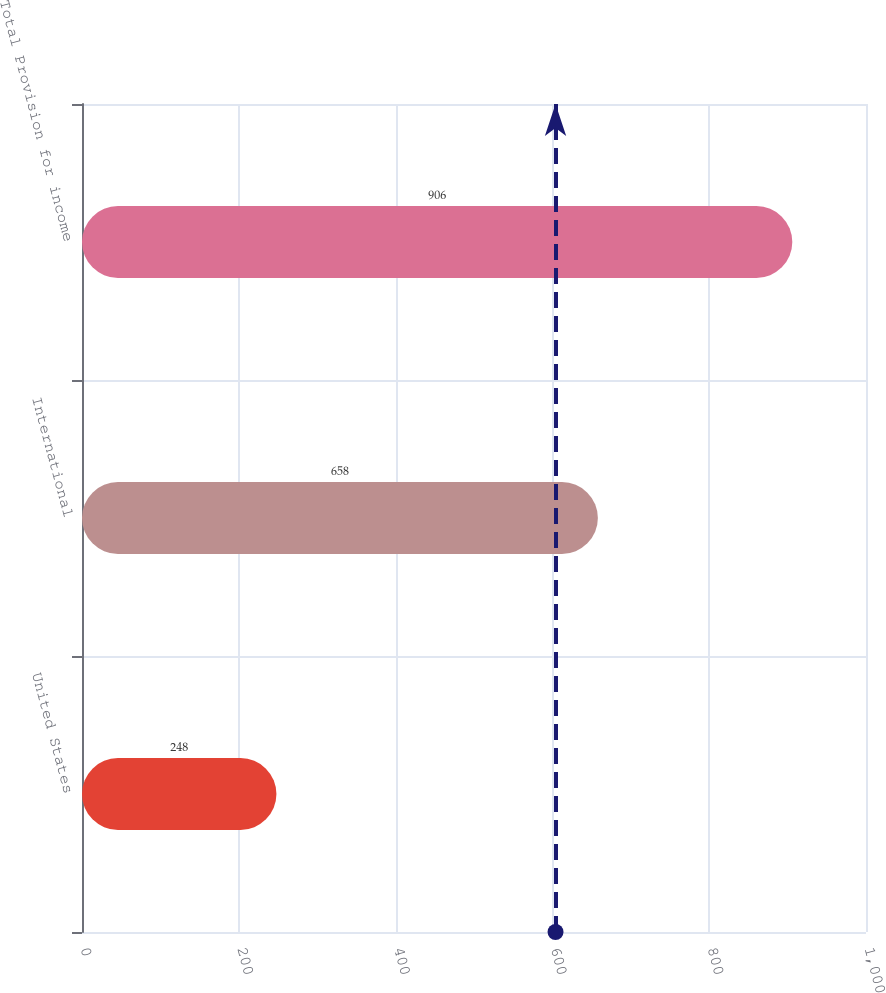Convert chart to OTSL. <chart><loc_0><loc_0><loc_500><loc_500><bar_chart><fcel>United States<fcel>International<fcel>Total Provision for income<nl><fcel>248<fcel>658<fcel>906<nl></chart> 